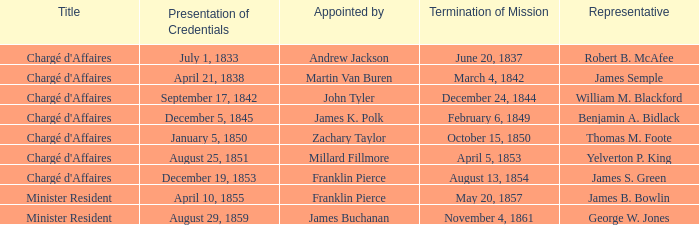What Representative has a Presentation of Credentails of April 10, 1855? James B. Bowlin. 